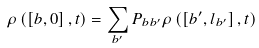Convert formula to latex. <formula><loc_0><loc_0><loc_500><loc_500>\rho \left ( \left [ b , 0 \right ] , t \right ) = \sum _ { b ^ { \prime } } P _ { b b ^ { \prime } } \rho \left ( \left [ b ^ { \prime } , l _ { b ^ { \prime } } \right ] , t \right )</formula> 